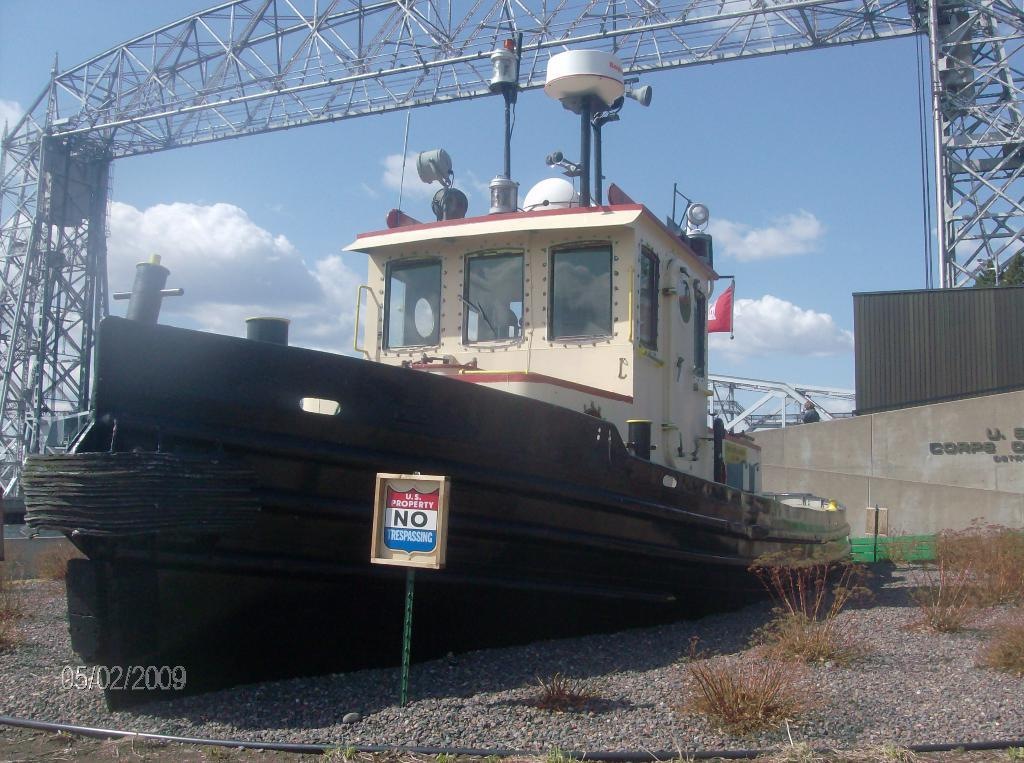What is the main subject of the image? The main subject of the image is a boat. What other objects or elements can be seen in the image? There are plants, stones, a board, a wall, and an arch visible in the image. What is the background of the image? The sky is visible in the background of the image, with clouds present. What type of mint is being used to tie the string around the boat in the image? There is no mint or string present in the image; it only features a boat, plants, stones, a board, a wall, an arch, and the sky with clouds. 